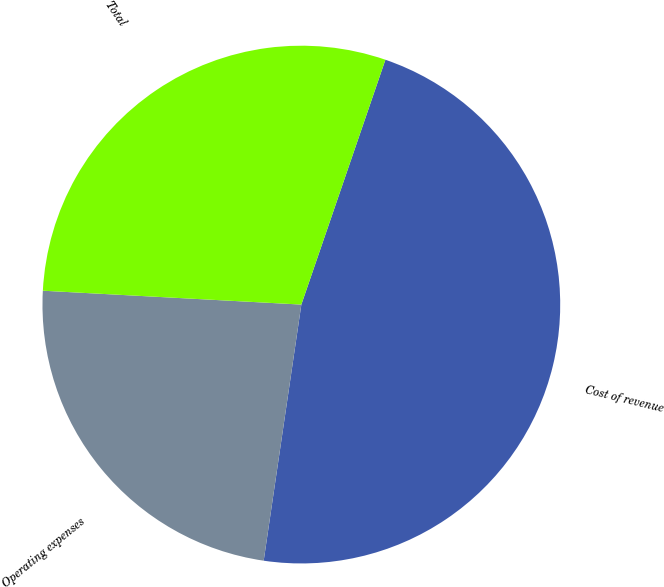<chart> <loc_0><loc_0><loc_500><loc_500><pie_chart><fcel>Cost of revenue<fcel>Operating expenses<fcel>Total<nl><fcel>47.06%<fcel>23.53%<fcel>29.41%<nl></chart> 